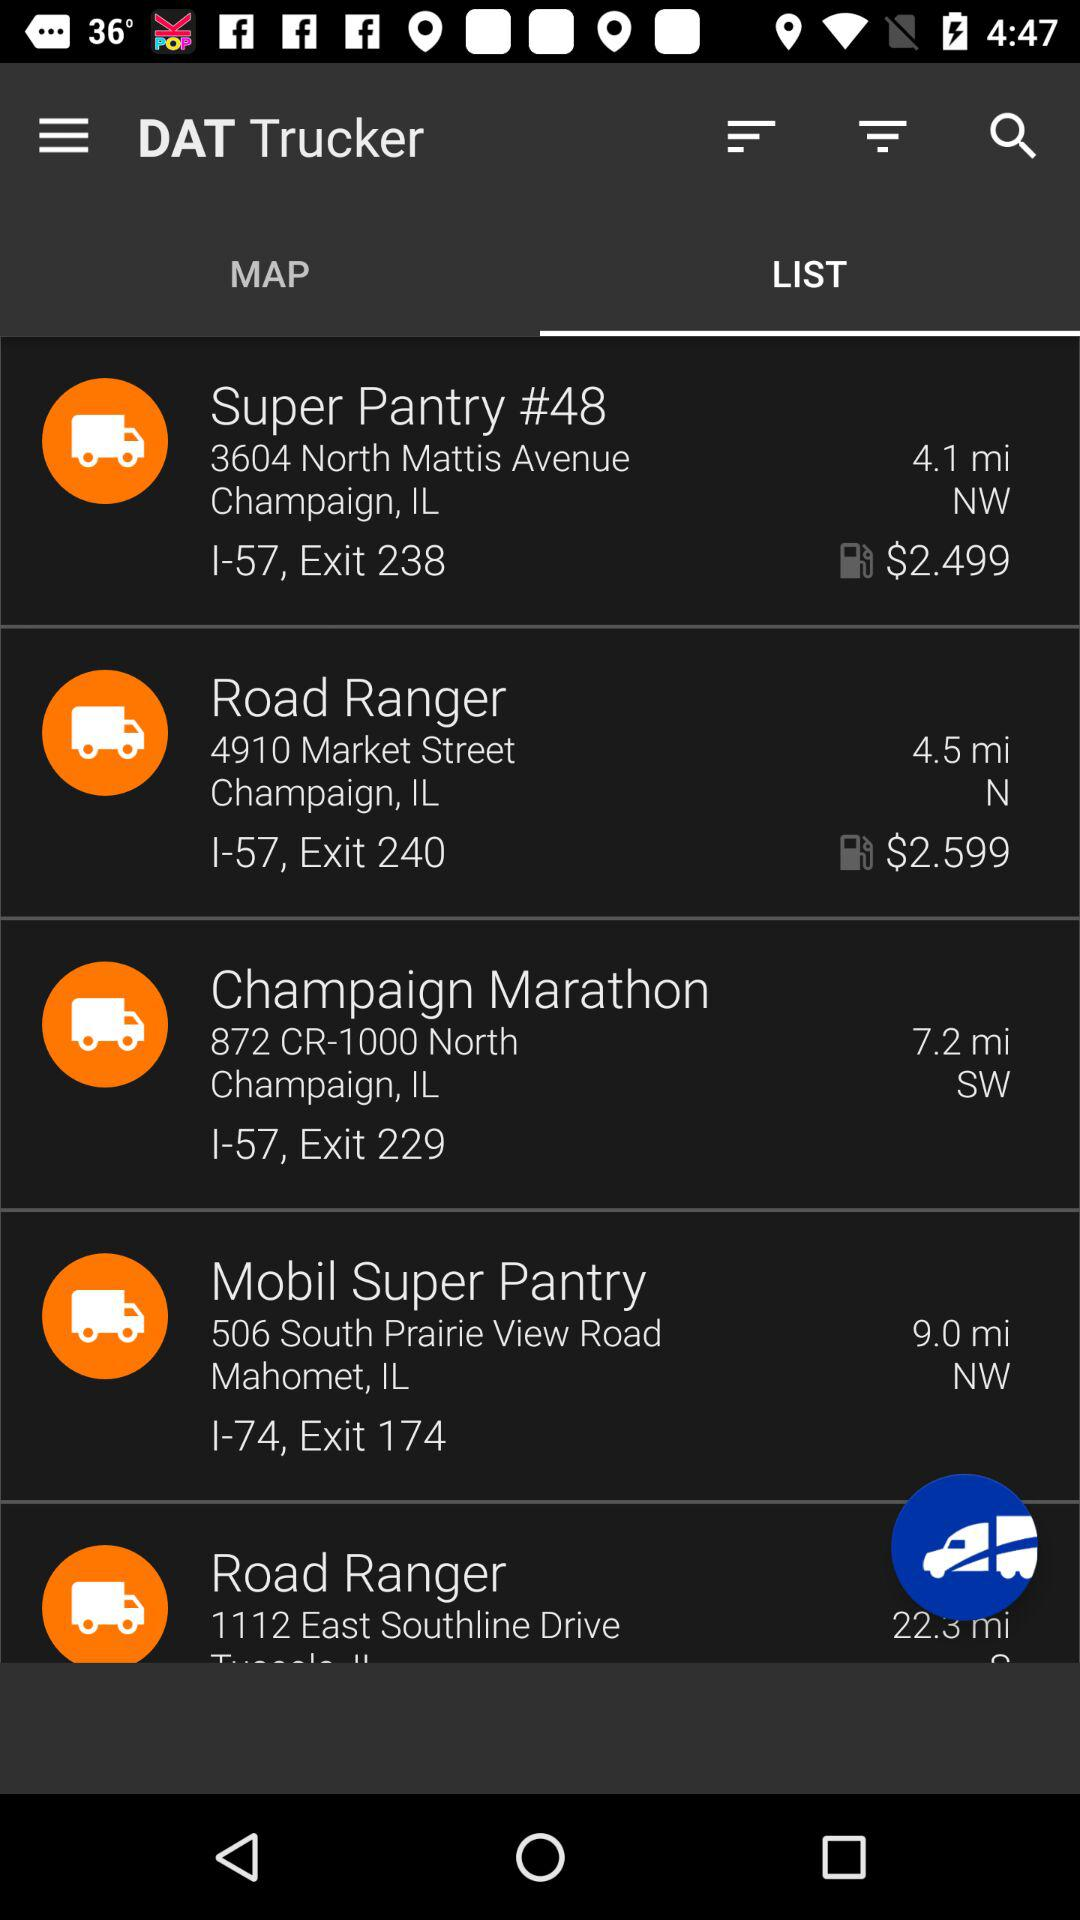What tab are we on? We are on the "LIST" tab. 